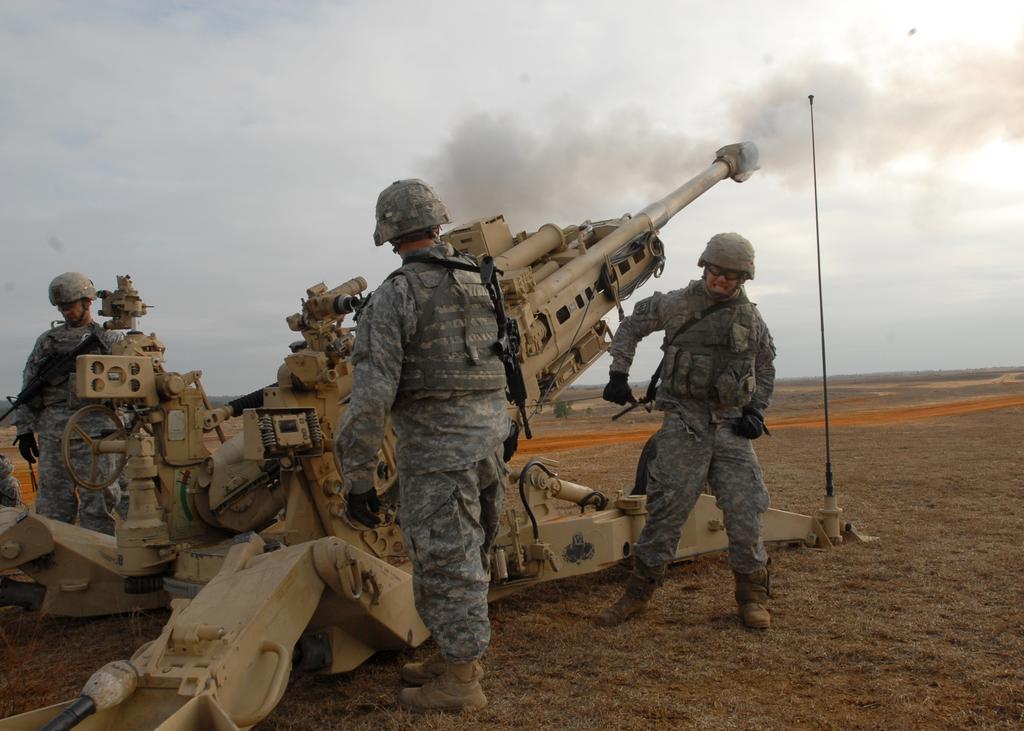Can you describe this image briefly? In this picture we can see there are three people standing on the path and in front of the people there is a machine. Behind the people there is smoke and a cloudy sky. 